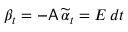<formula> <loc_0><loc_0><loc_500><loc_500>\beta _ { t } = - A \, \widetilde { \alpha } _ { t } = E \, d t</formula> 